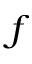Convert formula to latex. <formula><loc_0><loc_0><loc_500><loc_500>f</formula> 